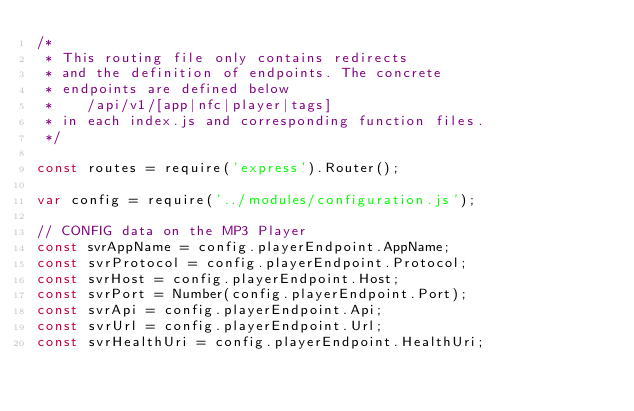<code> <loc_0><loc_0><loc_500><loc_500><_JavaScript_>/*
 * This routing file only contains redirects
 * and the definition of endpoints. The concrete
 * endpoints are defined below
 *    /api/v1/[app|nfc|player|tags]
 * in each index.js and corresponding function files.
 */

const routes = require('express').Router();

var config = require('../modules/configuration.js');

// CONFIG data on the MP3 Player
const svrAppName = config.playerEndpoint.AppName;
const svrProtocol = config.playerEndpoint.Protocol;
const svrHost = config.playerEndpoint.Host;
const svrPort = Number(config.playerEndpoint.Port);
const svrApi = config.playerEndpoint.Api;
const svrUrl = config.playerEndpoint.Url;
const svrHealthUri = config.playerEndpoint.HealthUri;</code> 